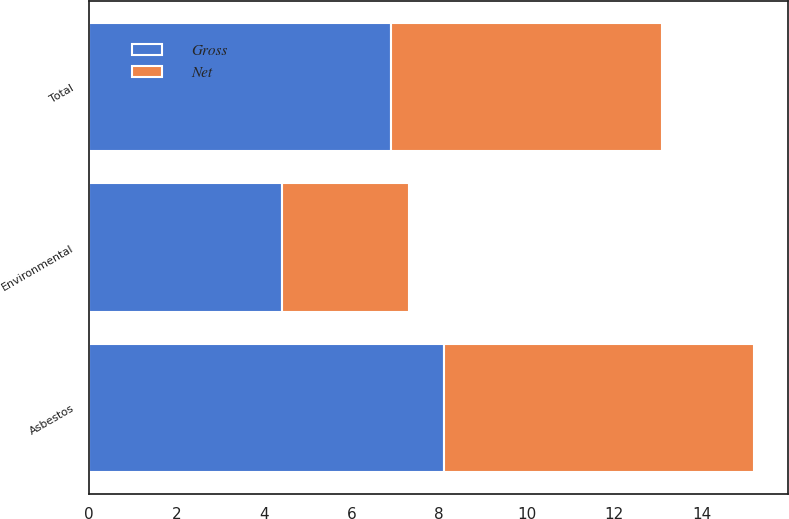Convert chart to OTSL. <chart><loc_0><loc_0><loc_500><loc_500><stacked_bar_chart><ecel><fcel>Asbestos<fcel>Environmental<fcel>Total<nl><fcel>Net<fcel>7.1<fcel>2.9<fcel>6.2<nl><fcel>Gross<fcel>8.1<fcel>4.4<fcel>6.9<nl></chart> 